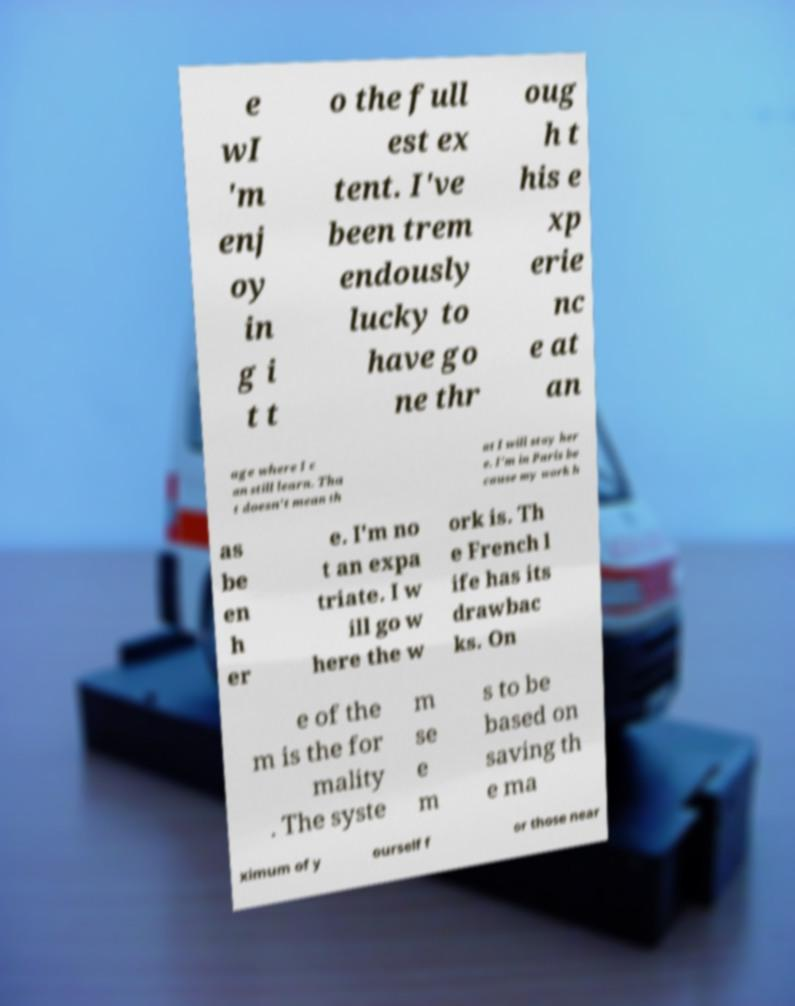I need the written content from this picture converted into text. Can you do that? e wI 'm enj oy in g i t t o the full est ex tent. I've been trem endously lucky to have go ne thr oug h t his e xp erie nc e at an age where I c an still learn. Tha t doesn't mean th at I will stay her e. I'm in Paris be cause my work h as be en h er e. I'm no t an expa triate. I w ill go w here the w ork is. Th e French l ife has its drawbac ks. On e of the m is the for mality . The syste m se e m s to be based on saving th e ma ximum of y ourself f or those near 